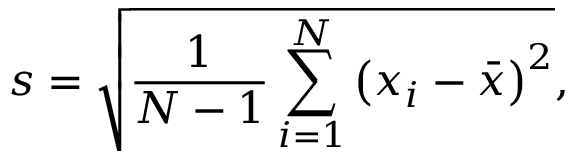<formula> <loc_0><loc_0><loc_500><loc_500>s = { \sqrt { { \frac { 1 } { N - 1 } } \sum _ { i = 1 } ^ { N } \left ( x _ { i } - { \bar { x } } \right ) ^ { 2 } } } ,</formula> 